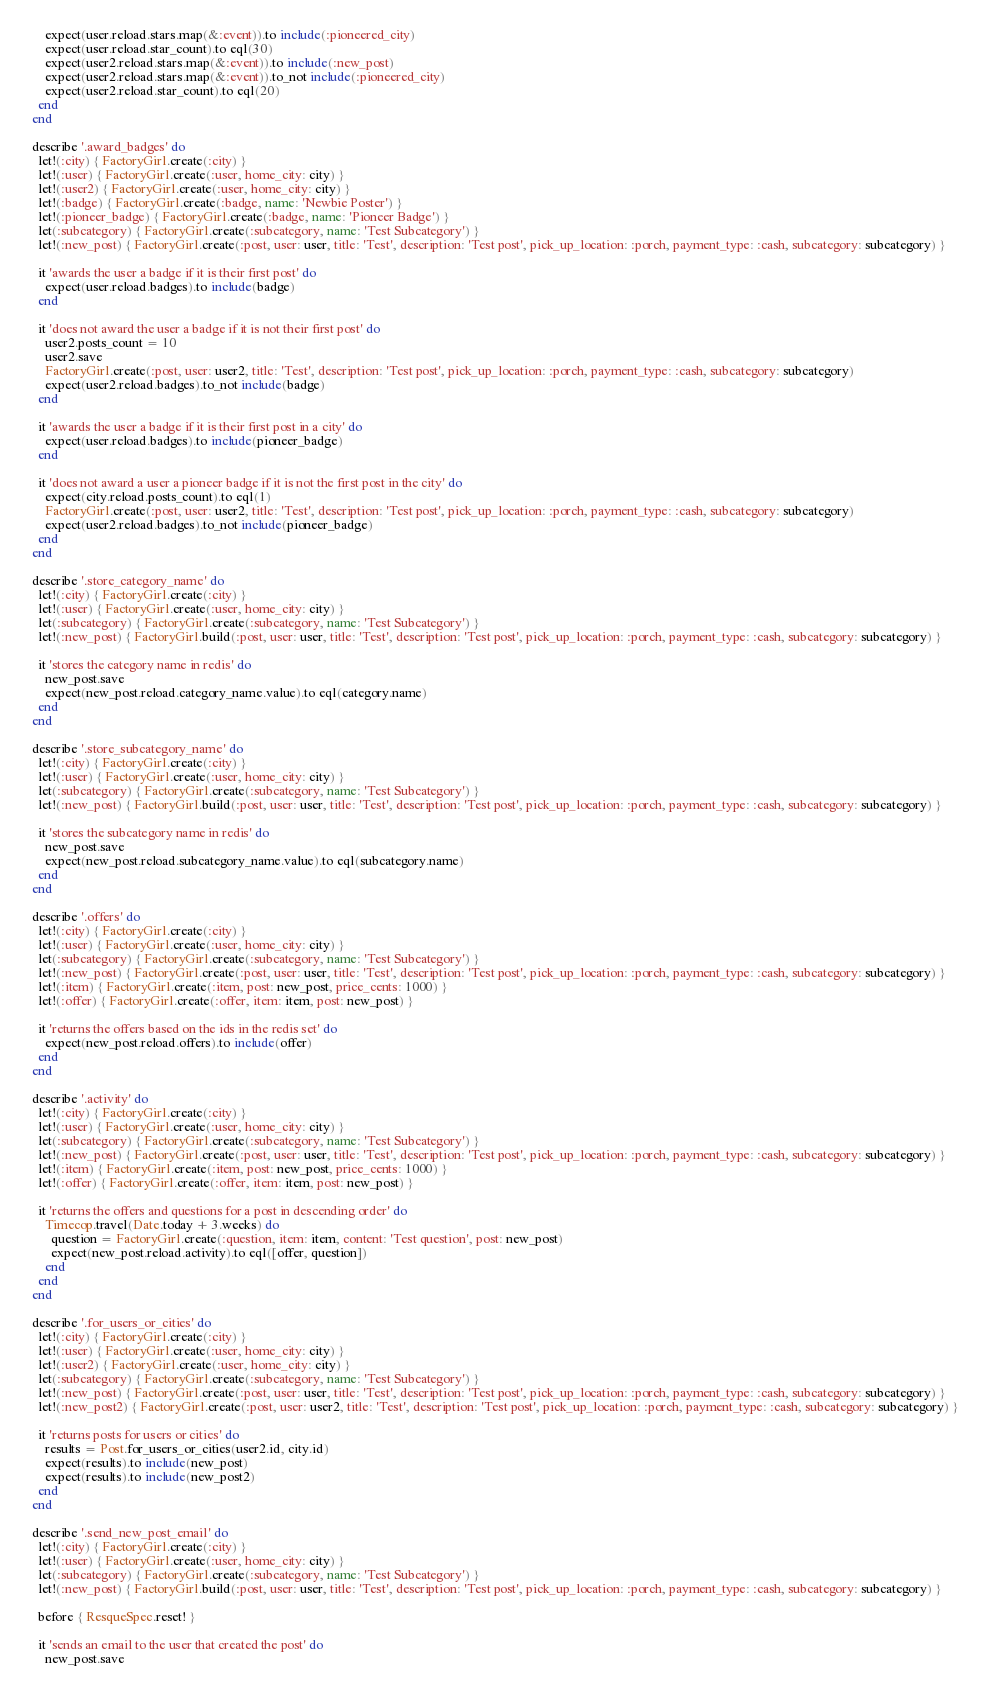Convert code to text. <code><loc_0><loc_0><loc_500><loc_500><_Ruby_>      expect(user.reload.stars.map(&:event)).to include(:pioneered_city)
      expect(user.reload.star_count).to eql(30)
      expect(user2.reload.stars.map(&:event)).to include(:new_post)
      expect(user2.reload.stars.map(&:event)).to_not include(:pioneered_city)
      expect(user2.reload.star_count).to eql(20)
    end
  end

  describe '.award_badges' do
    let!(:city) { FactoryGirl.create(:city) }
    let!(:user) { FactoryGirl.create(:user, home_city: city) }
    let!(:user2) { FactoryGirl.create(:user, home_city: city) }
    let!(:badge) { FactoryGirl.create(:badge, name: 'Newbie Poster') }
    let!(:pioneer_badge) { FactoryGirl.create(:badge, name: 'Pioneer Badge') }
    let(:subcategory) { FactoryGirl.create(:subcategory, name: 'Test Subcategory') }
    let!(:new_post) { FactoryGirl.create(:post, user: user, title: 'Test', description: 'Test post', pick_up_location: :porch, payment_type: :cash, subcategory: subcategory) }
    
    it 'awards the user a badge if it is their first post' do
      expect(user.reload.badges).to include(badge)
    end

    it 'does not award the user a badge if it is not their first post' do
      user2.posts_count = 10
      user2.save
      FactoryGirl.create(:post, user: user2, title: 'Test', description: 'Test post', pick_up_location: :porch, payment_type: :cash, subcategory: subcategory)
      expect(user2.reload.badges).to_not include(badge)
    end

    it 'awards the user a badge if it is their first post in a city' do
      expect(user.reload.badges).to include(pioneer_badge)
    end

    it 'does not award a user a pioneer badge if it is not the first post in the city' do
      expect(city.reload.posts_count).to eql(1)
      FactoryGirl.create(:post, user: user2, title: 'Test', description: 'Test post', pick_up_location: :porch, payment_type: :cash, subcategory: subcategory)
      expect(user2.reload.badges).to_not include(pioneer_badge)
    end
  end

  describe '.store_category_name' do
    let!(:city) { FactoryGirl.create(:city) }
    let!(:user) { FactoryGirl.create(:user, home_city: city) }
    let(:subcategory) { FactoryGirl.create(:subcategory, name: 'Test Subcategory') }
    let!(:new_post) { FactoryGirl.build(:post, user: user, title: 'Test', description: 'Test post', pick_up_location: :porch, payment_type: :cash, subcategory: subcategory) }

    it 'stores the category name in redis' do
      new_post.save
      expect(new_post.reload.category_name.value).to eql(category.name)
    end
  end

  describe '.store_subcategory_name' do
    let!(:city) { FactoryGirl.create(:city) }
    let!(:user) { FactoryGirl.create(:user, home_city: city) }
    let(:subcategory) { FactoryGirl.create(:subcategory, name: 'Test Subcategory') }
    let!(:new_post) { FactoryGirl.build(:post, user: user, title: 'Test', description: 'Test post', pick_up_location: :porch, payment_type: :cash, subcategory: subcategory) }

    it 'stores the subcategory name in redis' do
      new_post.save
      expect(new_post.reload.subcategory_name.value).to eql(subcategory.name)
    end
  end

  describe '.offers' do
    let!(:city) { FactoryGirl.create(:city) }
    let!(:user) { FactoryGirl.create(:user, home_city: city) }
    let(:subcategory) { FactoryGirl.create(:subcategory, name: 'Test Subcategory') }
    let!(:new_post) { FactoryGirl.create(:post, user: user, title: 'Test', description: 'Test post', pick_up_location: :porch, payment_type: :cash, subcategory: subcategory) }
    let!(:item) { FactoryGirl.create(:item, post: new_post, price_cents: 1000) }
    let!(:offer) { FactoryGirl.create(:offer, item: item, post: new_post) }

    it 'returns the offers based on the ids in the redis set' do
      expect(new_post.reload.offers).to include(offer)
    end
  end

  describe '.activity' do
    let!(:city) { FactoryGirl.create(:city) }
    let!(:user) { FactoryGirl.create(:user, home_city: city) }
    let(:subcategory) { FactoryGirl.create(:subcategory, name: 'Test Subcategory') }
    let!(:new_post) { FactoryGirl.create(:post, user: user, title: 'Test', description: 'Test post', pick_up_location: :porch, payment_type: :cash, subcategory: subcategory) }
    let!(:item) { FactoryGirl.create(:item, post: new_post, price_cents: 1000) }
    let!(:offer) { FactoryGirl.create(:offer, item: item, post: new_post) }

    it 'returns the offers and questions for a post in descending order' do
      Timecop.travel(Date.today + 3.weeks) do
        question = FactoryGirl.create(:question, item: item, content: 'Test question', post: new_post)
        expect(new_post.reload.activity).to eql([offer, question])
      end
    end
  end

  describe '.for_users_or_cities' do
    let!(:city) { FactoryGirl.create(:city) }
    let!(:user) { FactoryGirl.create(:user, home_city: city) }
    let!(:user2) { FactoryGirl.create(:user, home_city: city) }
    let(:subcategory) { FactoryGirl.create(:subcategory, name: 'Test Subcategory') }
    let!(:new_post) { FactoryGirl.create(:post, user: user, title: 'Test', description: 'Test post', pick_up_location: :porch, payment_type: :cash, subcategory: subcategory) }
    let!(:new_post2) { FactoryGirl.create(:post, user: user2, title: 'Test', description: 'Test post', pick_up_location: :porch, payment_type: :cash, subcategory: subcategory) }

    it 'returns posts for users or cities' do
      results = Post.for_users_or_cities(user2.id, city.id)
      expect(results).to include(new_post)
      expect(results).to include(new_post2)
    end
  end

  describe '.send_new_post_email' do
    let!(:city) { FactoryGirl.create(:city) }
    let!(:user) { FactoryGirl.create(:user, home_city: city) }
    let(:subcategory) { FactoryGirl.create(:subcategory, name: 'Test Subcategory') }
    let!(:new_post) { FactoryGirl.build(:post, user: user, title: 'Test', description: 'Test post', pick_up_location: :porch, payment_type: :cash, subcategory: subcategory) }

    before { ResqueSpec.reset! }

    it 'sends an email to the user that created the post' do
      new_post.save</code> 